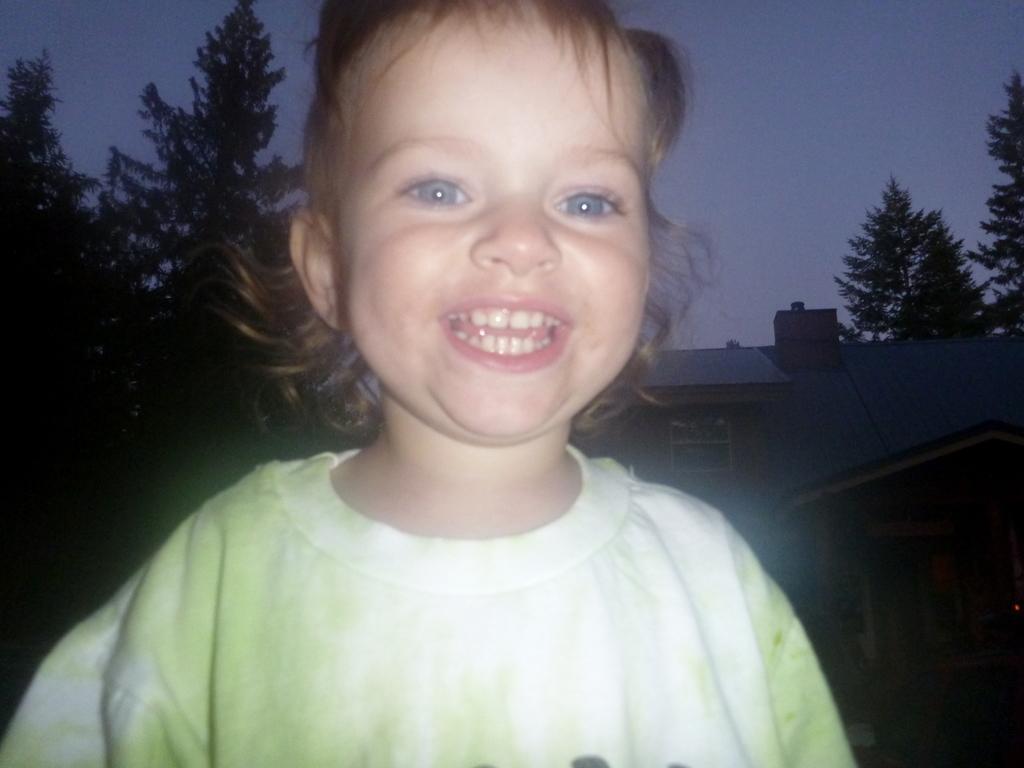Could you give a brief overview of what you see in this image? In this picture we can see a girl smiling. Behind this girl, we can see a house on the right side. There are some trees visible in the background. We can see the sky in the background. 